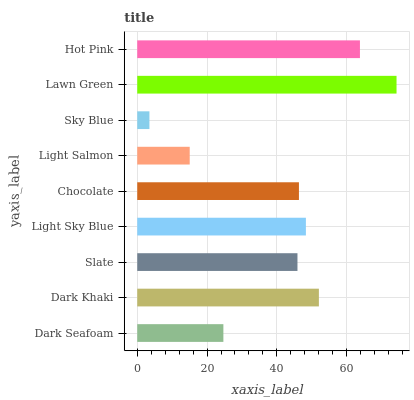Is Sky Blue the minimum?
Answer yes or no. Yes. Is Lawn Green the maximum?
Answer yes or no. Yes. Is Dark Khaki the minimum?
Answer yes or no. No. Is Dark Khaki the maximum?
Answer yes or no. No. Is Dark Khaki greater than Dark Seafoam?
Answer yes or no. Yes. Is Dark Seafoam less than Dark Khaki?
Answer yes or no. Yes. Is Dark Seafoam greater than Dark Khaki?
Answer yes or no. No. Is Dark Khaki less than Dark Seafoam?
Answer yes or no. No. Is Chocolate the high median?
Answer yes or no. Yes. Is Chocolate the low median?
Answer yes or no. Yes. Is Slate the high median?
Answer yes or no. No. Is Dark Seafoam the low median?
Answer yes or no. No. 